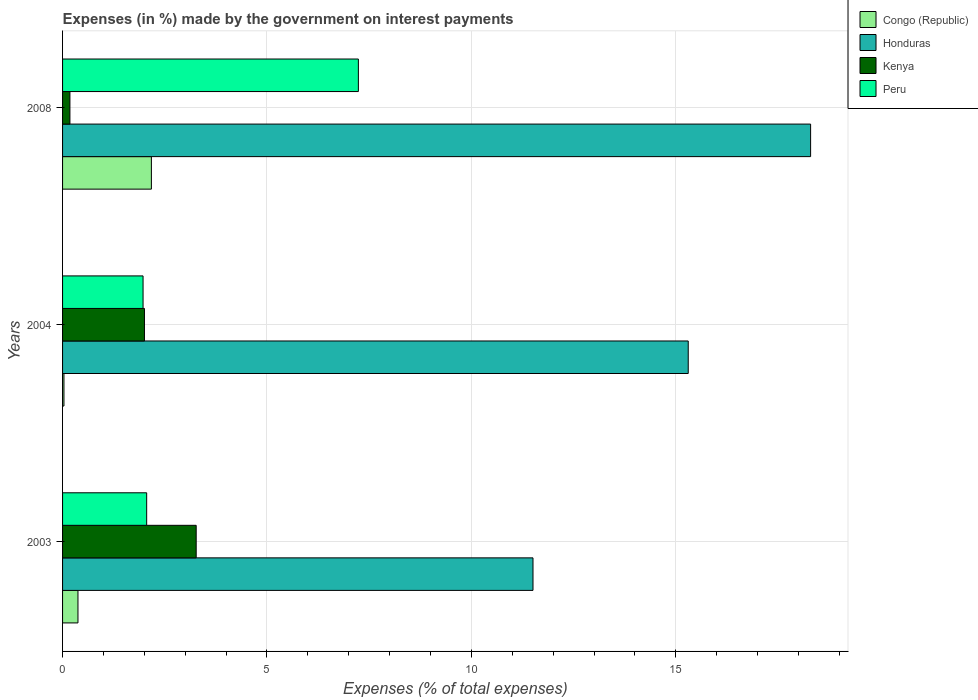How many groups of bars are there?
Keep it short and to the point. 3. How many bars are there on the 2nd tick from the top?
Your answer should be compact. 4. In how many cases, is the number of bars for a given year not equal to the number of legend labels?
Keep it short and to the point. 0. What is the percentage of expenses made by the government on interest payments in Congo (Republic) in 2003?
Ensure brevity in your answer.  0.38. Across all years, what is the maximum percentage of expenses made by the government on interest payments in Kenya?
Provide a short and direct response. 3.27. Across all years, what is the minimum percentage of expenses made by the government on interest payments in Honduras?
Your answer should be compact. 11.51. In which year was the percentage of expenses made by the government on interest payments in Peru minimum?
Give a very brief answer. 2004. What is the total percentage of expenses made by the government on interest payments in Kenya in the graph?
Give a very brief answer. 5.45. What is the difference between the percentage of expenses made by the government on interest payments in Peru in 2003 and that in 2008?
Offer a very short reply. -5.18. What is the difference between the percentage of expenses made by the government on interest payments in Peru in 2008 and the percentage of expenses made by the government on interest payments in Congo (Republic) in 2003?
Give a very brief answer. 6.86. What is the average percentage of expenses made by the government on interest payments in Honduras per year?
Your response must be concise. 15.04. In the year 2003, what is the difference between the percentage of expenses made by the government on interest payments in Congo (Republic) and percentage of expenses made by the government on interest payments in Honduras?
Offer a very short reply. -11.13. In how many years, is the percentage of expenses made by the government on interest payments in Peru greater than 5 %?
Ensure brevity in your answer.  1. What is the ratio of the percentage of expenses made by the government on interest payments in Peru in 2003 to that in 2004?
Keep it short and to the point. 1.05. Is the difference between the percentage of expenses made by the government on interest payments in Congo (Republic) in 2003 and 2004 greater than the difference between the percentage of expenses made by the government on interest payments in Honduras in 2003 and 2004?
Your response must be concise. Yes. What is the difference between the highest and the second highest percentage of expenses made by the government on interest payments in Peru?
Your answer should be compact. 5.18. What is the difference between the highest and the lowest percentage of expenses made by the government on interest payments in Congo (Republic)?
Your answer should be compact. 2.14. What does the 2nd bar from the top in 2003 represents?
Offer a terse response. Kenya. What does the 2nd bar from the bottom in 2004 represents?
Keep it short and to the point. Honduras. Is it the case that in every year, the sum of the percentage of expenses made by the government on interest payments in Honduras and percentage of expenses made by the government on interest payments in Kenya is greater than the percentage of expenses made by the government on interest payments in Peru?
Give a very brief answer. Yes. How many bars are there?
Make the answer very short. 12. What is the difference between two consecutive major ticks on the X-axis?
Ensure brevity in your answer.  5. Are the values on the major ticks of X-axis written in scientific E-notation?
Ensure brevity in your answer.  No. What is the title of the graph?
Offer a terse response. Expenses (in %) made by the government on interest payments. What is the label or title of the X-axis?
Your answer should be compact. Expenses (% of total expenses). What is the Expenses (% of total expenses) of Congo (Republic) in 2003?
Provide a succinct answer. 0.38. What is the Expenses (% of total expenses) in Honduras in 2003?
Your answer should be compact. 11.51. What is the Expenses (% of total expenses) of Kenya in 2003?
Your answer should be compact. 3.27. What is the Expenses (% of total expenses) in Peru in 2003?
Keep it short and to the point. 2.06. What is the Expenses (% of total expenses) in Congo (Republic) in 2004?
Your answer should be compact. 0.03. What is the Expenses (% of total expenses) of Honduras in 2004?
Keep it short and to the point. 15.3. What is the Expenses (% of total expenses) of Kenya in 2004?
Your response must be concise. 2. What is the Expenses (% of total expenses) of Peru in 2004?
Your answer should be very brief. 1.97. What is the Expenses (% of total expenses) in Congo (Republic) in 2008?
Provide a short and direct response. 2.17. What is the Expenses (% of total expenses) in Honduras in 2008?
Your answer should be very brief. 18.3. What is the Expenses (% of total expenses) of Kenya in 2008?
Give a very brief answer. 0.18. What is the Expenses (% of total expenses) in Peru in 2008?
Ensure brevity in your answer.  7.24. Across all years, what is the maximum Expenses (% of total expenses) of Congo (Republic)?
Your answer should be very brief. 2.17. Across all years, what is the maximum Expenses (% of total expenses) in Honduras?
Make the answer very short. 18.3. Across all years, what is the maximum Expenses (% of total expenses) in Kenya?
Keep it short and to the point. 3.27. Across all years, what is the maximum Expenses (% of total expenses) in Peru?
Your answer should be compact. 7.24. Across all years, what is the minimum Expenses (% of total expenses) in Congo (Republic)?
Offer a terse response. 0.03. Across all years, what is the minimum Expenses (% of total expenses) of Honduras?
Keep it short and to the point. 11.51. Across all years, what is the minimum Expenses (% of total expenses) of Kenya?
Keep it short and to the point. 0.18. Across all years, what is the minimum Expenses (% of total expenses) in Peru?
Your answer should be compact. 1.97. What is the total Expenses (% of total expenses) in Congo (Republic) in the graph?
Offer a very short reply. 2.58. What is the total Expenses (% of total expenses) in Honduras in the graph?
Offer a very short reply. 45.11. What is the total Expenses (% of total expenses) in Kenya in the graph?
Offer a terse response. 5.45. What is the total Expenses (% of total expenses) of Peru in the graph?
Offer a terse response. 11.26. What is the difference between the Expenses (% of total expenses) in Congo (Republic) in 2003 and that in 2004?
Make the answer very short. 0.34. What is the difference between the Expenses (% of total expenses) of Honduras in 2003 and that in 2004?
Provide a short and direct response. -3.8. What is the difference between the Expenses (% of total expenses) in Kenya in 2003 and that in 2004?
Give a very brief answer. 1.27. What is the difference between the Expenses (% of total expenses) in Peru in 2003 and that in 2004?
Offer a terse response. 0.09. What is the difference between the Expenses (% of total expenses) in Congo (Republic) in 2003 and that in 2008?
Ensure brevity in your answer.  -1.8. What is the difference between the Expenses (% of total expenses) in Honduras in 2003 and that in 2008?
Your response must be concise. -6.79. What is the difference between the Expenses (% of total expenses) of Kenya in 2003 and that in 2008?
Provide a succinct answer. 3.09. What is the difference between the Expenses (% of total expenses) of Peru in 2003 and that in 2008?
Make the answer very short. -5.18. What is the difference between the Expenses (% of total expenses) in Congo (Republic) in 2004 and that in 2008?
Give a very brief answer. -2.14. What is the difference between the Expenses (% of total expenses) of Honduras in 2004 and that in 2008?
Make the answer very short. -2.99. What is the difference between the Expenses (% of total expenses) of Kenya in 2004 and that in 2008?
Your answer should be compact. 1.82. What is the difference between the Expenses (% of total expenses) in Peru in 2004 and that in 2008?
Offer a very short reply. -5.27. What is the difference between the Expenses (% of total expenses) of Congo (Republic) in 2003 and the Expenses (% of total expenses) of Honduras in 2004?
Your response must be concise. -14.93. What is the difference between the Expenses (% of total expenses) of Congo (Republic) in 2003 and the Expenses (% of total expenses) of Kenya in 2004?
Keep it short and to the point. -1.63. What is the difference between the Expenses (% of total expenses) of Congo (Republic) in 2003 and the Expenses (% of total expenses) of Peru in 2004?
Provide a short and direct response. -1.59. What is the difference between the Expenses (% of total expenses) of Honduras in 2003 and the Expenses (% of total expenses) of Kenya in 2004?
Ensure brevity in your answer.  9.5. What is the difference between the Expenses (% of total expenses) of Honduras in 2003 and the Expenses (% of total expenses) of Peru in 2004?
Ensure brevity in your answer.  9.54. What is the difference between the Expenses (% of total expenses) of Kenya in 2003 and the Expenses (% of total expenses) of Peru in 2004?
Your response must be concise. 1.3. What is the difference between the Expenses (% of total expenses) in Congo (Republic) in 2003 and the Expenses (% of total expenses) in Honduras in 2008?
Keep it short and to the point. -17.92. What is the difference between the Expenses (% of total expenses) of Congo (Republic) in 2003 and the Expenses (% of total expenses) of Kenya in 2008?
Offer a terse response. 0.2. What is the difference between the Expenses (% of total expenses) of Congo (Republic) in 2003 and the Expenses (% of total expenses) of Peru in 2008?
Keep it short and to the point. -6.86. What is the difference between the Expenses (% of total expenses) in Honduras in 2003 and the Expenses (% of total expenses) in Kenya in 2008?
Provide a short and direct response. 11.33. What is the difference between the Expenses (% of total expenses) in Honduras in 2003 and the Expenses (% of total expenses) in Peru in 2008?
Keep it short and to the point. 4.27. What is the difference between the Expenses (% of total expenses) of Kenya in 2003 and the Expenses (% of total expenses) of Peru in 2008?
Keep it short and to the point. -3.97. What is the difference between the Expenses (% of total expenses) of Congo (Republic) in 2004 and the Expenses (% of total expenses) of Honduras in 2008?
Make the answer very short. -18.26. What is the difference between the Expenses (% of total expenses) in Congo (Republic) in 2004 and the Expenses (% of total expenses) in Kenya in 2008?
Keep it short and to the point. -0.15. What is the difference between the Expenses (% of total expenses) in Congo (Republic) in 2004 and the Expenses (% of total expenses) in Peru in 2008?
Your answer should be compact. -7.2. What is the difference between the Expenses (% of total expenses) of Honduras in 2004 and the Expenses (% of total expenses) of Kenya in 2008?
Offer a terse response. 15.12. What is the difference between the Expenses (% of total expenses) of Honduras in 2004 and the Expenses (% of total expenses) of Peru in 2008?
Offer a very short reply. 8.07. What is the difference between the Expenses (% of total expenses) of Kenya in 2004 and the Expenses (% of total expenses) of Peru in 2008?
Your response must be concise. -5.23. What is the average Expenses (% of total expenses) in Congo (Republic) per year?
Provide a succinct answer. 0.86. What is the average Expenses (% of total expenses) in Honduras per year?
Provide a short and direct response. 15.04. What is the average Expenses (% of total expenses) in Kenya per year?
Your response must be concise. 1.82. What is the average Expenses (% of total expenses) in Peru per year?
Your response must be concise. 3.75. In the year 2003, what is the difference between the Expenses (% of total expenses) in Congo (Republic) and Expenses (% of total expenses) in Honduras?
Your answer should be compact. -11.13. In the year 2003, what is the difference between the Expenses (% of total expenses) of Congo (Republic) and Expenses (% of total expenses) of Kenya?
Give a very brief answer. -2.89. In the year 2003, what is the difference between the Expenses (% of total expenses) of Congo (Republic) and Expenses (% of total expenses) of Peru?
Your answer should be compact. -1.68. In the year 2003, what is the difference between the Expenses (% of total expenses) in Honduras and Expenses (% of total expenses) in Kenya?
Offer a terse response. 8.24. In the year 2003, what is the difference between the Expenses (% of total expenses) in Honduras and Expenses (% of total expenses) in Peru?
Provide a short and direct response. 9.45. In the year 2003, what is the difference between the Expenses (% of total expenses) in Kenya and Expenses (% of total expenses) in Peru?
Make the answer very short. 1.21. In the year 2004, what is the difference between the Expenses (% of total expenses) of Congo (Republic) and Expenses (% of total expenses) of Honduras?
Your answer should be very brief. -15.27. In the year 2004, what is the difference between the Expenses (% of total expenses) of Congo (Republic) and Expenses (% of total expenses) of Kenya?
Ensure brevity in your answer.  -1.97. In the year 2004, what is the difference between the Expenses (% of total expenses) of Congo (Republic) and Expenses (% of total expenses) of Peru?
Make the answer very short. -1.93. In the year 2004, what is the difference between the Expenses (% of total expenses) in Honduras and Expenses (% of total expenses) in Kenya?
Ensure brevity in your answer.  13.3. In the year 2004, what is the difference between the Expenses (% of total expenses) of Honduras and Expenses (% of total expenses) of Peru?
Give a very brief answer. 13.34. In the year 2004, what is the difference between the Expenses (% of total expenses) of Kenya and Expenses (% of total expenses) of Peru?
Your answer should be very brief. 0.03. In the year 2008, what is the difference between the Expenses (% of total expenses) of Congo (Republic) and Expenses (% of total expenses) of Honduras?
Give a very brief answer. -16.12. In the year 2008, what is the difference between the Expenses (% of total expenses) in Congo (Republic) and Expenses (% of total expenses) in Kenya?
Your answer should be very brief. 1.99. In the year 2008, what is the difference between the Expenses (% of total expenses) in Congo (Republic) and Expenses (% of total expenses) in Peru?
Make the answer very short. -5.06. In the year 2008, what is the difference between the Expenses (% of total expenses) in Honduras and Expenses (% of total expenses) in Kenya?
Provide a succinct answer. 18.12. In the year 2008, what is the difference between the Expenses (% of total expenses) of Honduras and Expenses (% of total expenses) of Peru?
Your answer should be compact. 11.06. In the year 2008, what is the difference between the Expenses (% of total expenses) in Kenya and Expenses (% of total expenses) in Peru?
Offer a very short reply. -7.06. What is the ratio of the Expenses (% of total expenses) of Congo (Republic) in 2003 to that in 2004?
Your response must be concise. 11.12. What is the ratio of the Expenses (% of total expenses) of Honduras in 2003 to that in 2004?
Provide a short and direct response. 0.75. What is the ratio of the Expenses (% of total expenses) of Kenya in 2003 to that in 2004?
Offer a very short reply. 1.63. What is the ratio of the Expenses (% of total expenses) of Peru in 2003 to that in 2004?
Offer a very short reply. 1.04. What is the ratio of the Expenses (% of total expenses) of Congo (Republic) in 2003 to that in 2008?
Keep it short and to the point. 0.17. What is the ratio of the Expenses (% of total expenses) of Honduras in 2003 to that in 2008?
Keep it short and to the point. 0.63. What is the ratio of the Expenses (% of total expenses) in Kenya in 2003 to that in 2008?
Provide a succinct answer. 18.17. What is the ratio of the Expenses (% of total expenses) in Peru in 2003 to that in 2008?
Offer a terse response. 0.28. What is the ratio of the Expenses (% of total expenses) of Congo (Republic) in 2004 to that in 2008?
Give a very brief answer. 0.02. What is the ratio of the Expenses (% of total expenses) of Honduras in 2004 to that in 2008?
Keep it short and to the point. 0.84. What is the ratio of the Expenses (% of total expenses) in Kenya in 2004 to that in 2008?
Offer a terse response. 11.13. What is the ratio of the Expenses (% of total expenses) of Peru in 2004 to that in 2008?
Offer a very short reply. 0.27. What is the difference between the highest and the second highest Expenses (% of total expenses) in Congo (Republic)?
Give a very brief answer. 1.8. What is the difference between the highest and the second highest Expenses (% of total expenses) of Honduras?
Offer a terse response. 2.99. What is the difference between the highest and the second highest Expenses (% of total expenses) in Kenya?
Your response must be concise. 1.27. What is the difference between the highest and the second highest Expenses (% of total expenses) in Peru?
Your answer should be very brief. 5.18. What is the difference between the highest and the lowest Expenses (% of total expenses) of Congo (Republic)?
Ensure brevity in your answer.  2.14. What is the difference between the highest and the lowest Expenses (% of total expenses) of Honduras?
Give a very brief answer. 6.79. What is the difference between the highest and the lowest Expenses (% of total expenses) in Kenya?
Ensure brevity in your answer.  3.09. What is the difference between the highest and the lowest Expenses (% of total expenses) in Peru?
Offer a very short reply. 5.27. 